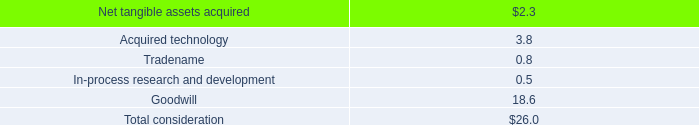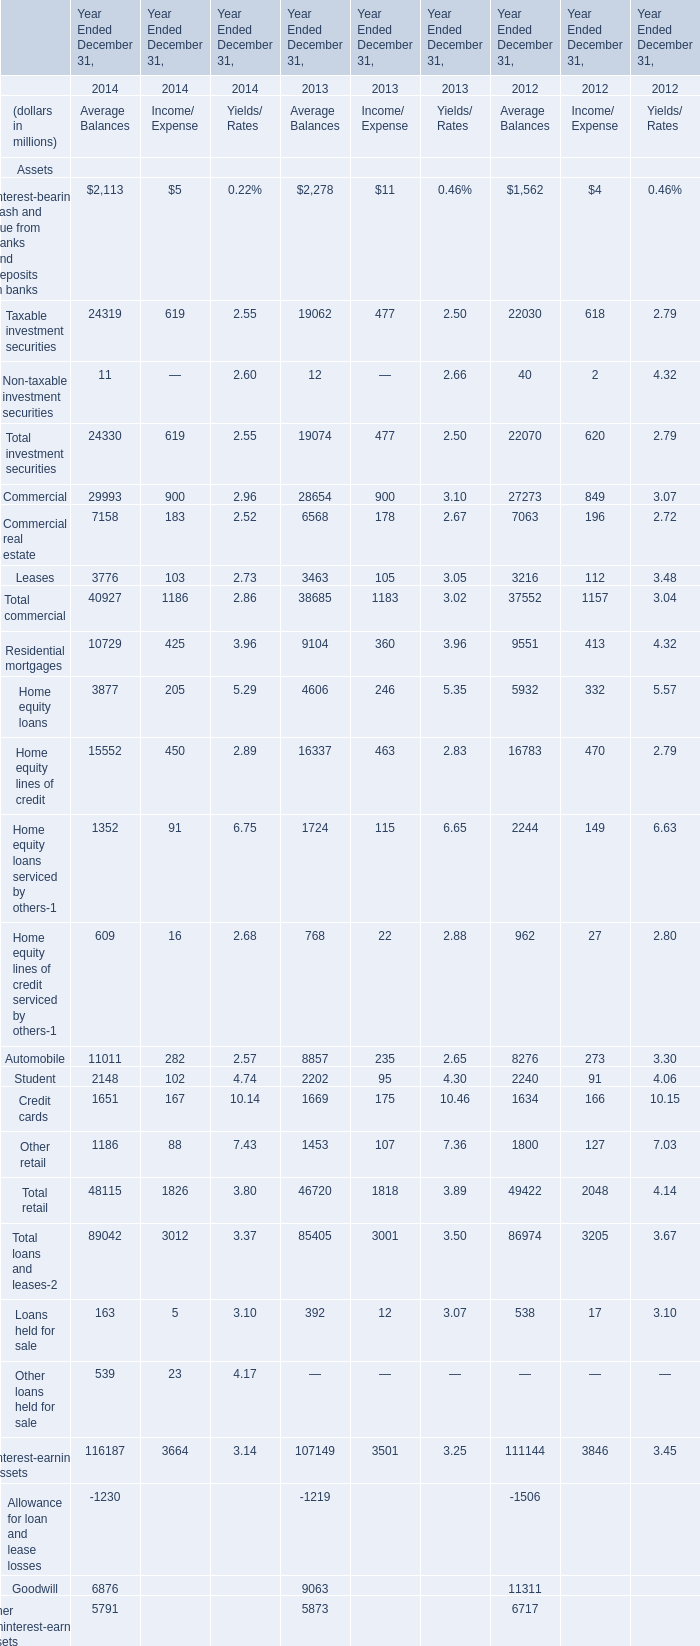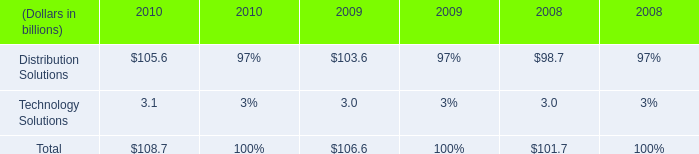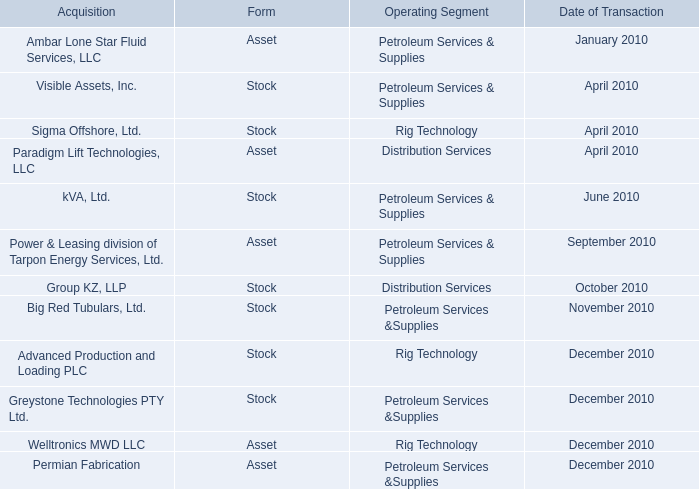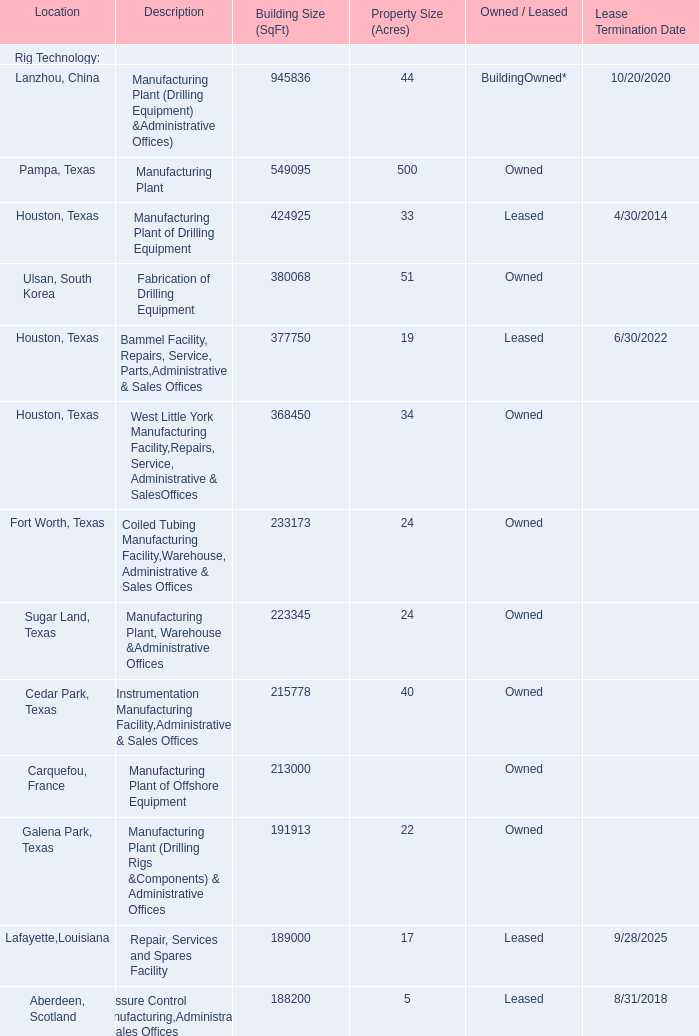What will Taxable investment securities of Average Balances reach in 2015 if it continues to grow at its current rate? (in million) 
Computations: (24319 * (1 + ((24319 - 19062) / 24319)))
Answer: 29576.0. 